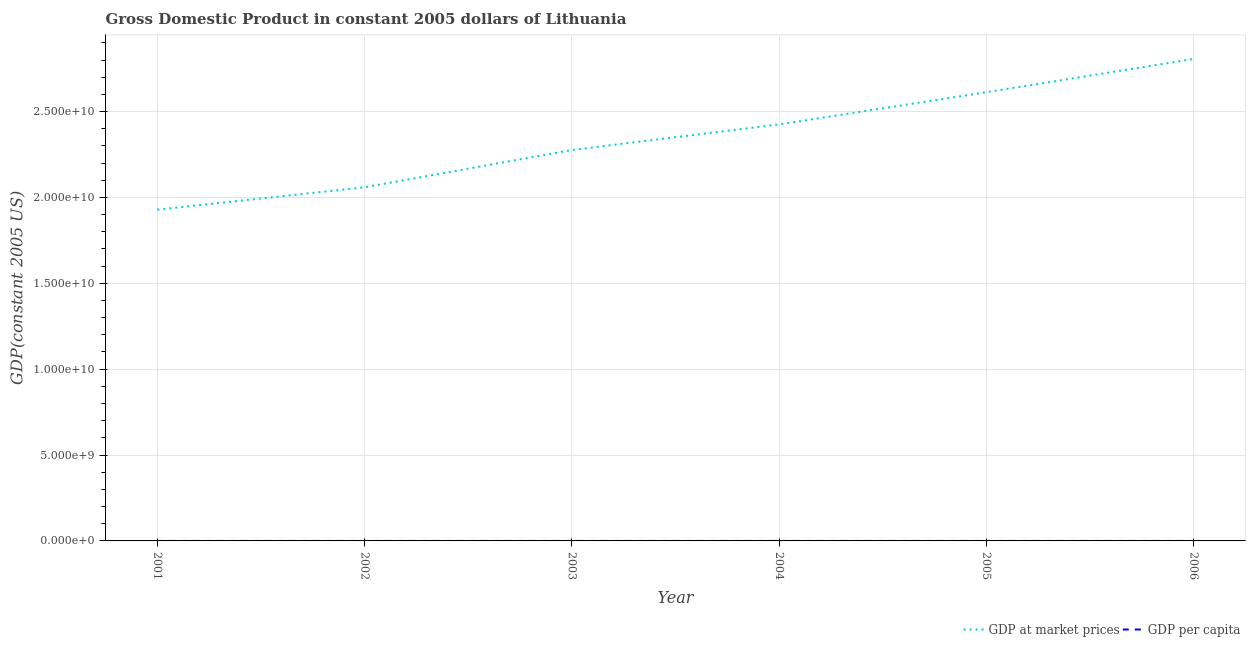Does the line corresponding to gdp at market prices intersect with the line corresponding to gdp per capita?
Make the answer very short. No. Is the number of lines equal to the number of legend labels?
Offer a very short reply. Yes. What is the gdp per capita in 2006?
Keep it short and to the point. 8581.45. Across all years, what is the maximum gdp at market prices?
Make the answer very short. 2.81e+1. Across all years, what is the minimum gdp per capita?
Offer a very short reply. 5556.85. In which year was the gdp at market prices maximum?
Your answer should be compact. 2006. What is the total gdp at market prices in the graph?
Ensure brevity in your answer.  1.41e+11. What is the difference between the gdp per capita in 2001 and that in 2003?
Offer a terse response. -1107.66. What is the difference between the gdp at market prices in 2005 and the gdp per capita in 2001?
Offer a terse response. 2.61e+1. What is the average gdp per capita per year?
Provide a succinct answer. 6971.26. In the year 2001, what is the difference between the gdp at market prices and gdp per capita?
Your answer should be very brief. 1.93e+1. What is the ratio of the gdp at market prices in 2001 to that in 2003?
Offer a very short reply. 0.85. Is the difference between the gdp at market prices in 2001 and 2003 greater than the difference between the gdp per capita in 2001 and 2003?
Make the answer very short. No. What is the difference between the highest and the second highest gdp per capita?
Your answer should be very brief. 718.29. What is the difference between the highest and the lowest gdp at market prices?
Give a very brief answer. 8.77e+09. Is the sum of the gdp at market prices in 2003 and 2005 greater than the maximum gdp per capita across all years?
Your response must be concise. Yes. Is the gdp at market prices strictly less than the gdp per capita over the years?
Offer a terse response. No. How many years are there in the graph?
Offer a terse response. 6. Does the graph contain any zero values?
Provide a succinct answer. No. How many legend labels are there?
Provide a succinct answer. 2. What is the title of the graph?
Provide a succinct answer. Gross Domestic Product in constant 2005 dollars of Lithuania. Does "Age 15+" appear as one of the legend labels in the graph?
Provide a short and direct response. No. What is the label or title of the Y-axis?
Your answer should be very brief. GDP(constant 2005 US). What is the GDP(constant 2005 US) in GDP at market prices in 2001?
Provide a short and direct response. 1.93e+1. What is the GDP(constant 2005 US) of GDP per capita in 2001?
Keep it short and to the point. 5556.85. What is the GDP(constant 2005 US) of GDP at market prices in 2002?
Provide a short and direct response. 2.06e+1. What is the GDP(constant 2005 US) in GDP per capita in 2002?
Make the answer very short. 5980.35. What is the GDP(constant 2005 US) in GDP at market prices in 2003?
Make the answer very short. 2.28e+1. What is the GDP(constant 2005 US) in GDP per capita in 2003?
Your response must be concise. 6664.51. What is the GDP(constant 2005 US) in GDP at market prices in 2004?
Offer a terse response. 2.43e+1. What is the GDP(constant 2005 US) in GDP per capita in 2004?
Make the answer very short. 7181.23. What is the GDP(constant 2005 US) in GDP at market prices in 2005?
Offer a terse response. 2.61e+1. What is the GDP(constant 2005 US) of GDP per capita in 2005?
Your answer should be compact. 7863.16. What is the GDP(constant 2005 US) in GDP at market prices in 2006?
Offer a very short reply. 2.81e+1. What is the GDP(constant 2005 US) in GDP per capita in 2006?
Keep it short and to the point. 8581.45. Across all years, what is the maximum GDP(constant 2005 US) in GDP at market prices?
Give a very brief answer. 2.81e+1. Across all years, what is the maximum GDP(constant 2005 US) in GDP per capita?
Offer a very short reply. 8581.45. Across all years, what is the minimum GDP(constant 2005 US) of GDP at market prices?
Ensure brevity in your answer.  1.93e+1. Across all years, what is the minimum GDP(constant 2005 US) in GDP per capita?
Offer a very short reply. 5556.85. What is the total GDP(constant 2005 US) in GDP at market prices in the graph?
Your response must be concise. 1.41e+11. What is the total GDP(constant 2005 US) in GDP per capita in the graph?
Keep it short and to the point. 4.18e+04. What is the difference between the GDP(constant 2005 US) in GDP at market prices in 2001 and that in 2002?
Keep it short and to the point. -1.30e+09. What is the difference between the GDP(constant 2005 US) of GDP per capita in 2001 and that in 2002?
Your answer should be very brief. -423.5. What is the difference between the GDP(constant 2005 US) of GDP at market prices in 2001 and that in 2003?
Keep it short and to the point. -3.47e+09. What is the difference between the GDP(constant 2005 US) of GDP per capita in 2001 and that in 2003?
Offer a terse response. -1107.66. What is the difference between the GDP(constant 2005 US) of GDP at market prices in 2001 and that in 2004?
Give a very brief answer. -4.96e+09. What is the difference between the GDP(constant 2005 US) in GDP per capita in 2001 and that in 2004?
Offer a very short reply. -1624.38. What is the difference between the GDP(constant 2005 US) in GDP at market prices in 2001 and that in 2005?
Give a very brief answer. -6.84e+09. What is the difference between the GDP(constant 2005 US) of GDP per capita in 2001 and that in 2005?
Ensure brevity in your answer.  -2306.31. What is the difference between the GDP(constant 2005 US) of GDP at market prices in 2001 and that in 2006?
Provide a succinct answer. -8.77e+09. What is the difference between the GDP(constant 2005 US) of GDP per capita in 2001 and that in 2006?
Ensure brevity in your answer.  -3024.6. What is the difference between the GDP(constant 2005 US) in GDP at market prices in 2002 and that in 2003?
Provide a short and direct response. -2.17e+09. What is the difference between the GDP(constant 2005 US) in GDP per capita in 2002 and that in 2003?
Your answer should be compact. -684.16. What is the difference between the GDP(constant 2005 US) in GDP at market prices in 2002 and that in 2004?
Keep it short and to the point. -3.66e+09. What is the difference between the GDP(constant 2005 US) of GDP per capita in 2002 and that in 2004?
Provide a succinct answer. -1200.88. What is the difference between the GDP(constant 2005 US) of GDP at market prices in 2002 and that in 2005?
Ensure brevity in your answer.  -5.53e+09. What is the difference between the GDP(constant 2005 US) of GDP per capita in 2002 and that in 2005?
Provide a succinct answer. -1882.81. What is the difference between the GDP(constant 2005 US) in GDP at market prices in 2002 and that in 2006?
Provide a succinct answer. -7.47e+09. What is the difference between the GDP(constant 2005 US) in GDP per capita in 2002 and that in 2006?
Your answer should be very brief. -2601.1. What is the difference between the GDP(constant 2005 US) of GDP at market prices in 2003 and that in 2004?
Your answer should be very brief. -1.49e+09. What is the difference between the GDP(constant 2005 US) of GDP per capita in 2003 and that in 2004?
Offer a terse response. -516.72. What is the difference between the GDP(constant 2005 US) in GDP at market prices in 2003 and that in 2005?
Provide a succinct answer. -3.36e+09. What is the difference between the GDP(constant 2005 US) in GDP per capita in 2003 and that in 2005?
Offer a very short reply. -1198.65. What is the difference between the GDP(constant 2005 US) in GDP at market prices in 2003 and that in 2006?
Your response must be concise. -5.30e+09. What is the difference between the GDP(constant 2005 US) in GDP per capita in 2003 and that in 2006?
Provide a short and direct response. -1916.94. What is the difference between the GDP(constant 2005 US) of GDP at market prices in 2004 and that in 2005?
Your response must be concise. -1.87e+09. What is the difference between the GDP(constant 2005 US) in GDP per capita in 2004 and that in 2005?
Provide a short and direct response. -681.93. What is the difference between the GDP(constant 2005 US) in GDP at market prices in 2004 and that in 2006?
Give a very brief answer. -3.81e+09. What is the difference between the GDP(constant 2005 US) of GDP per capita in 2004 and that in 2006?
Ensure brevity in your answer.  -1400.22. What is the difference between the GDP(constant 2005 US) of GDP at market prices in 2005 and that in 2006?
Give a very brief answer. -1.93e+09. What is the difference between the GDP(constant 2005 US) in GDP per capita in 2005 and that in 2006?
Ensure brevity in your answer.  -718.29. What is the difference between the GDP(constant 2005 US) of GDP at market prices in 2001 and the GDP(constant 2005 US) of GDP per capita in 2002?
Ensure brevity in your answer.  1.93e+1. What is the difference between the GDP(constant 2005 US) in GDP at market prices in 2001 and the GDP(constant 2005 US) in GDP per capita in 2003?
Keep it short and to the point. 1.93e+1. What is the difference between the GDP(constant 2005 US) of GDP at market prices in 2001 and the GDP(constant 2005 US) of GDP per capita in 2004?
Offer a very short reply. 1.93e+1. What is the difference between the GDP(constant 2005 US) in GDP at market prices in 2001 and the GDP(constant 2005 US) in GDP per capita in 2005?
Offer a terse response. 1.93e+1. What is the difference between the GDP(constant 2005 US) in GDP at market prices in 2001 and the GDP(constant 2005 US) in GDP per capita in 2006?
Provide a succinct answer. 1.93e+1. What is the difference between the GDP(constant 2005 US) in GDP at market prices in 2002 and the GDP(constant 2005 US) in GDP per capita in 2003?
Your response must be concise. 2.06e+1. What is the difference between the GDP(constant 2005 US) in GDP at market prices in 2002 and the GDP(constant 2005 US) in GDP per capita in 2004?
Keep it short and to the point. 2.06e+1. What is the difference between the GDP(constant 2005 US) in GDP at market prices in 2002 and the GDP(constant 2005 US) in GDP per capita in 2005?
Your response must be concise. 2.06e+1. What is the difference between the GDP(constant 2005 US) in GDP at market prices in 2002 and the GDP(constant 2005 US) in GDP per capita in 2006?
Provide a short and direct response. 2.06e+1. What is the difference between the GDP(constant 2005 US) of GDP at market prices in 2003 and the GDP(constant 2005 US) of GDP per capita in 2004?
Provide a short and direct response. 2.28e+1. What is the difference between the GDP(constant 2005 US) in GDP at market prices in 2003 and the GDP(constant 2005 US) in GDP per capita in 2005?
Give a very brief answer. 2.28e+1. What is the difference between the GDP(constant 2005 US) in GDP at market prices in 2003 and the GDP(constant 2005 US) in GDP per capita in 2006?
Your response must be concise. 2.28e+1. What is the difference between the GDP(constant 2005 US) in GDP at market prices in 2004 and the GDP(constant 2005 US) in GDP per capita in 2005?
Ensure brevity in your answer.  2.43e+1. What is the difference between the GDP(constant 2005 US) in GDP at market prices in 2004 and the GDP(constant 2005 US) in GDP per capita in 2006?
Offer a very short reply. 2.43e+1. What is the difference between the GDP(constant 2005 US) in GDP at market prices in 2005 and the GDP(constant 2005 US) in GDP per capita in 2006?
Provide a succinct answer. 2.61e+1. What is the average GDP(constant 2005 US) in GDP at market prices per year?
Make the answer very short. 2.35e+1. What is the average GDP(constant 2005 US) of GDP per capita per year?
Your answer should be compact. 6971.26. In the year 2001, what is the difference between the GDP(constant 2005 US) of GDP at market prices and GDP(constant 2005 US) of GDP per capita?
Your response must be concise. 1.93e+1. In the year 2002, what is the difference between the GDP(constant 2005 US) in GDP at market prices and GDP(constant 2005 US) in GDP per capita?
Offer a very short reply. 2.06e+1. In the year 2003, what is the difference between the GDP(constant 2005 US) in GDP at market prices and GDP(constant 2005 US) in GDP per capita?
Offer a terse response. 2.28e+1. In the year 2004, what is the difference between the GDP(constant 2005 US) in GDP at market prices and GDP(constant 2005 US) in GDP per capita?
Offer a very short reply. 2.43e+1. In the year 2005, what is the difference between the GDP(constant 2005 US) of GDP at market prices and GDP(constant 2005 US) of GDP per capita?
Provide a succinct answer. 2.61e+1. In the year 2006, what is the difference between the GDP(constant 2005 US) of GDP at market prices and GDP(constant 2005 US) of GDP per capita?
Keep it short and to the point. 2.81e+1. What is the ratio of the GDP(constant 2005 US) in GDP at market prices in 2001 to that in 2002?
Provide a short and direct response. 0.94. What is the ratio of the GDP(constant 2005 US) of GDP per capita in 2001 to that in 2002?
Keep it short and to the point. 0.93. What is the ratio of the GDP(constant 2005 US) in GDP at market prices in 2001 to that in 2003?
Offer a terse response. 0.85. What is the ratio of the GDP(constant 2005 US) of GDP per capita in 2001 to that in 2003?
Provide a short and direct response. 0.83. What is the ratio of the GDP(constant 2005 US) in GDP at market prices in 2001 to that in 2004?
Your answer should be very brief. 0.8. What is the ratio of the GDP(constant 2005 US) in GDP per capita in 2001 to that in 2004?
Your answer should be compact. 0.77. What is the ratio of the GDP(constant 2005 US) of GDP at market prices in 2001 to that in 2005?
Make the answer very short. 0.74. What is the ratio of the GDP(constant 2005 US) of GDP per capita in 2001 to that in 2005?
Give a very brief answer. 0.71. What is the ratio of the GDP(constant 2005 US) of GDP at market prices in 2001 to that in 2006?
Offer a terse response. 0.69. What is the ratio of the GDP(constant 2005 US) of GDP per capita in 2001 to that in 2006?
Your answer should be very brief. 0.65. What is the ratio of the GDP(constant 2005 US) of GDP at market prices in 2002 to that in 2003?
Provide a short and direct response. 0.9. What is the ratio of the GDP(constant 2005 US) of GDP per capita in 2002 to that in 2003?
Your answer should be compact. 0.9. What is the ratio of the GDP(constant 2005 US) in GDP at market prices in 2002 to that in 2004?
Give a very brief answer. 0.85. What is the ratio of the GDP(constant 2005 US) in GDP per capita in 2002 to that in 2004?
Provide a succinct answer. 0.83. What is the ratio of the GDP(constant 2005 US) of GDP at market prices in 2002 to that in 2005?
Give a very brief answer. 0.79. What is the ratio of the GDP(constant 2005 US) in GDP per capita in 2002 to that in 2005?
Give a very brief answer. 0.76. What is the ratio of the GDP(constant 2005 US) in GDP at market prices in 2002 to that in 2006?
Ensure brevity in your answer.  0.73. What is the ratio of the GDP(constant 2005 US) in GDP per capita in 2002 to that in 2006?
Provide a short and direct response. 0.7. What is the ratio of the GDP(constant 2005 US) of GDP at market prices in 2003 to that in 2004?
Your answer should be very brief. 0.94. What is the ratio of the GDP(constant 2005 US) of GDP per capita in 2003 to that in 2004?
Ensure brevity in your answer.  0.93. What is the ratio of the GDP(constant 2005 US) in GDP at market prices in 2003 to that in 2005?
Provide a succinct answer. 0.87. What is the ratio of the GDP(constant 2005 US) in GDP per capita in 2003 to that in 2005?
Give a very brief answer. 0.85. What is the ratio of the GDP(constant 2005 US) in GDP at market prices in 2003 to that in 2006?
Provide a short and direct response. 0.81. What is the ratio of the GDP(constant 2005 US) of GDP per capita in 2003 to that in 2006?
Your answer should be compact. 0.78. What is the ratio of the GDP(constant 2005 US) in GDP at market prices in 2004 to that in 2005?
Your response must be concise. 0.93. What is the ratio of the GDP(constant 2005 US) of GDP per capita in 2004 to that in 2005?
Keep it short and to the point. 0.91. What is the ratio of the GDP(constant 2005 US) of GDP at market prices in 2004 to that in 2006?
Provide a succinct answer. 0.86. What is the ratio of the GDP(constant 2005 US) in GDP per capita in 2004 to that in 2006?
Provide a short and direct response. 0.84. What is the ratio of the GDP(constant 2005 US) in GDP at market prices in 2005 to that in 2006?
Keep it short and to the point. 0.93. What is the ratio of the GDP(constant 2005 US) of GDP per capita in 2005 to that in 2006?
Keep it short and to the point. 0.92. What is the difference between the highest and the second highest GDP(constant 2005 US) of GDP at market prices?
Your response must be concise. 1.93e+09. What is the difference between the highest and the second highest GDP(constant 2005 US) of GDP per capita?
Your answer should be compact. 718.29. What is the difference between the highest and the lowest GDP(constant 2005 US) in GDP at market prices?
Your answer should be compact. 8.77e+09. What is the difference between the highest and the lowest GDP(constant 2005 US) in GDP per capita?
Offer a very short reply. 3024.6. 